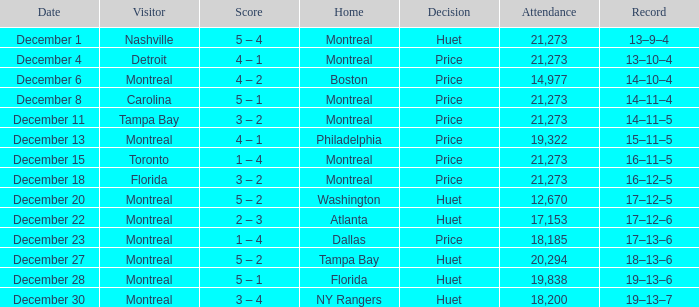What is the accomplishment on december 4? 13–10–4. 